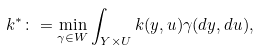<formula> <loc_0><loc_0><loc_500><loc_500>k ^ { * } \colon = \min _ { \gamma \in W } \int _ { Y \times U } k ( y , u ) \gamma ( d y , d u ) ,</formula> 